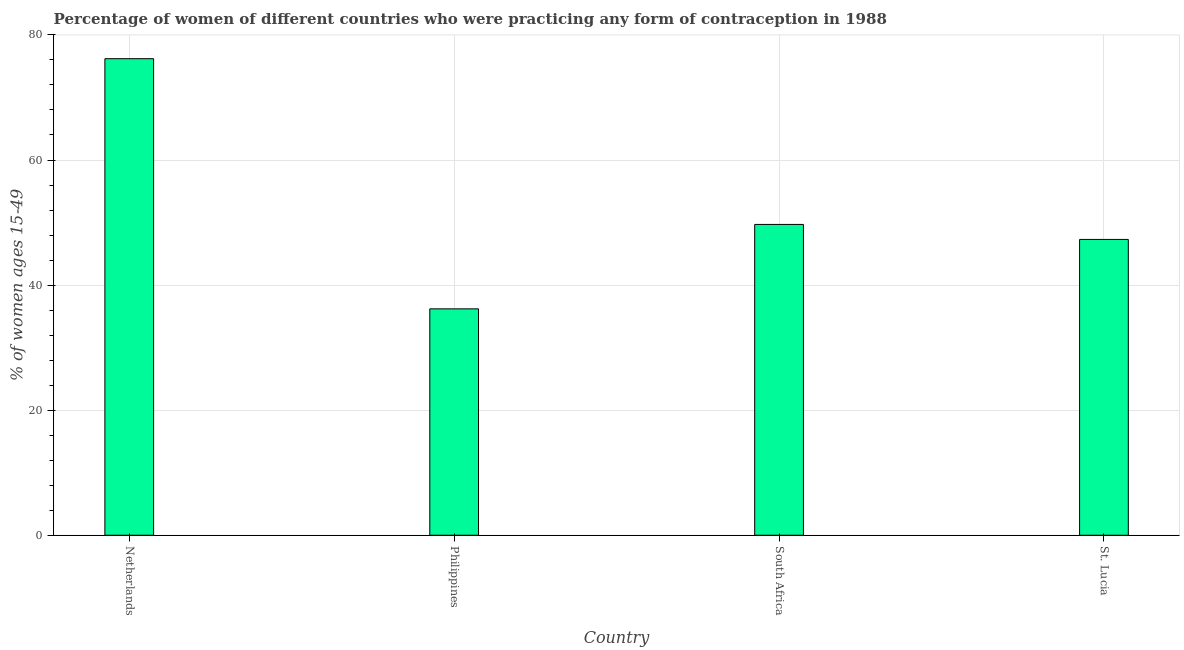Does the graph contain any zero values?
Ensure brevity in your answer.  No. Does the graph contain grids?
Provide a short and direct response. Yes. What is the title of the graph?
Your response must be concise. Percentage of women of different countries who were practicing any form of contraception in 1988. What is the label or title of the X-axis?
Offer a very short reply. Country. What is the label or title of the Y-axis?
Offer a very short reply. % of women ages 15-49. What is the contraceptive prevalence in St. Lucia?
Your answer should be very brief. 47.3. Across all countries, what is the maximum contraceptive prevalence?
Your answer should be very brief. 76.2. Across all countries, what is the minimum contraceptive prevalence?
Keep it short and to the point. 36.2. In which country was the contraceptive prevalence maximum?
Your answer should be very brief. Netherlands. What is the sum of the contraceptive prevalence?
Keep it short and to the point. 209.4. What is the average contraceptive prevalence per country?
Offer a very short reply. 52.35. What is the median contraceptive prevalence?
Provide a short and direct response. 48.5. What is the ratio of the contraceptive prevalence in Netherlands to that in St. Lucia?
Provide a short and direct response. 1.61. What is the difference between the highest and the second highest contraceptive prevalence?
Your response must be concise. 26.5. What is the difference between the highest and the lowest contraceptive prevalence?
Ensure brevity in your answer.  40. In how many countries, is the contraceptive prevalence greater than the average contraceptive prevalence taken over all countries?
Keep it short and to the point. 1. How many bars are there?
Give a very brief answer. 4. Are all the bars in the graph horizontal?
Your response must be concise. No. How many countries are there in the graph?
Make the answer very short. 4. What is the difference between two consecutive major ticks on the Y-axis?
Your answer should be compact. 20. Are the values on the major ticks of Y-axis written in scientific E-notation?
Offer a terse response. No. What is the % of women ages 15-49 of Netherlands?
Provide a succinct answer. 76.2. What is the % of women ages 15-49 in Philippines?
Offer a very short reply. 36.2. What is the % of women ages 15-49 of South Africa?
Your answer should be compact. 49.7. What is the % of women ages 15-49 in St. Lucia?
Provide a short and direct response. 47.3. What is the difference between the % of women ages 15-49 in Netherlands and Philippines?
Give a very brief answer. 40. What is the difference between the % of women ages 15-49 in Netherlands and St. Lucia?
Your answer should be very brief. 28.9. What is the ratio of the % of women ages 15-49 in Netherlands to that in Philippines?
Provide a succinct answer. 2.1. What is the ratio of the % of women ages 15-49 in Netherlands to that in South Africa?
Ensure brevity in your answer.  1.53. What is the ratio of the % of women ages 15-49 in Netherlands to that in St. Lucia?
Provide a succinct answer. 1.61. What is the ratio of the % of women ages 15-49 in Philippines to that in South Africa?
Ensure brevity in your answer.  0.73. What is the ratio of the % of women ages 15-49 in Philippines to that in St. Lucia?
Provide a short and direct response. 0.77. What is the ratio of the % of women ages 15-49 in South Africa to that in St. Lucia?
Make the answer very short. 1.05. 